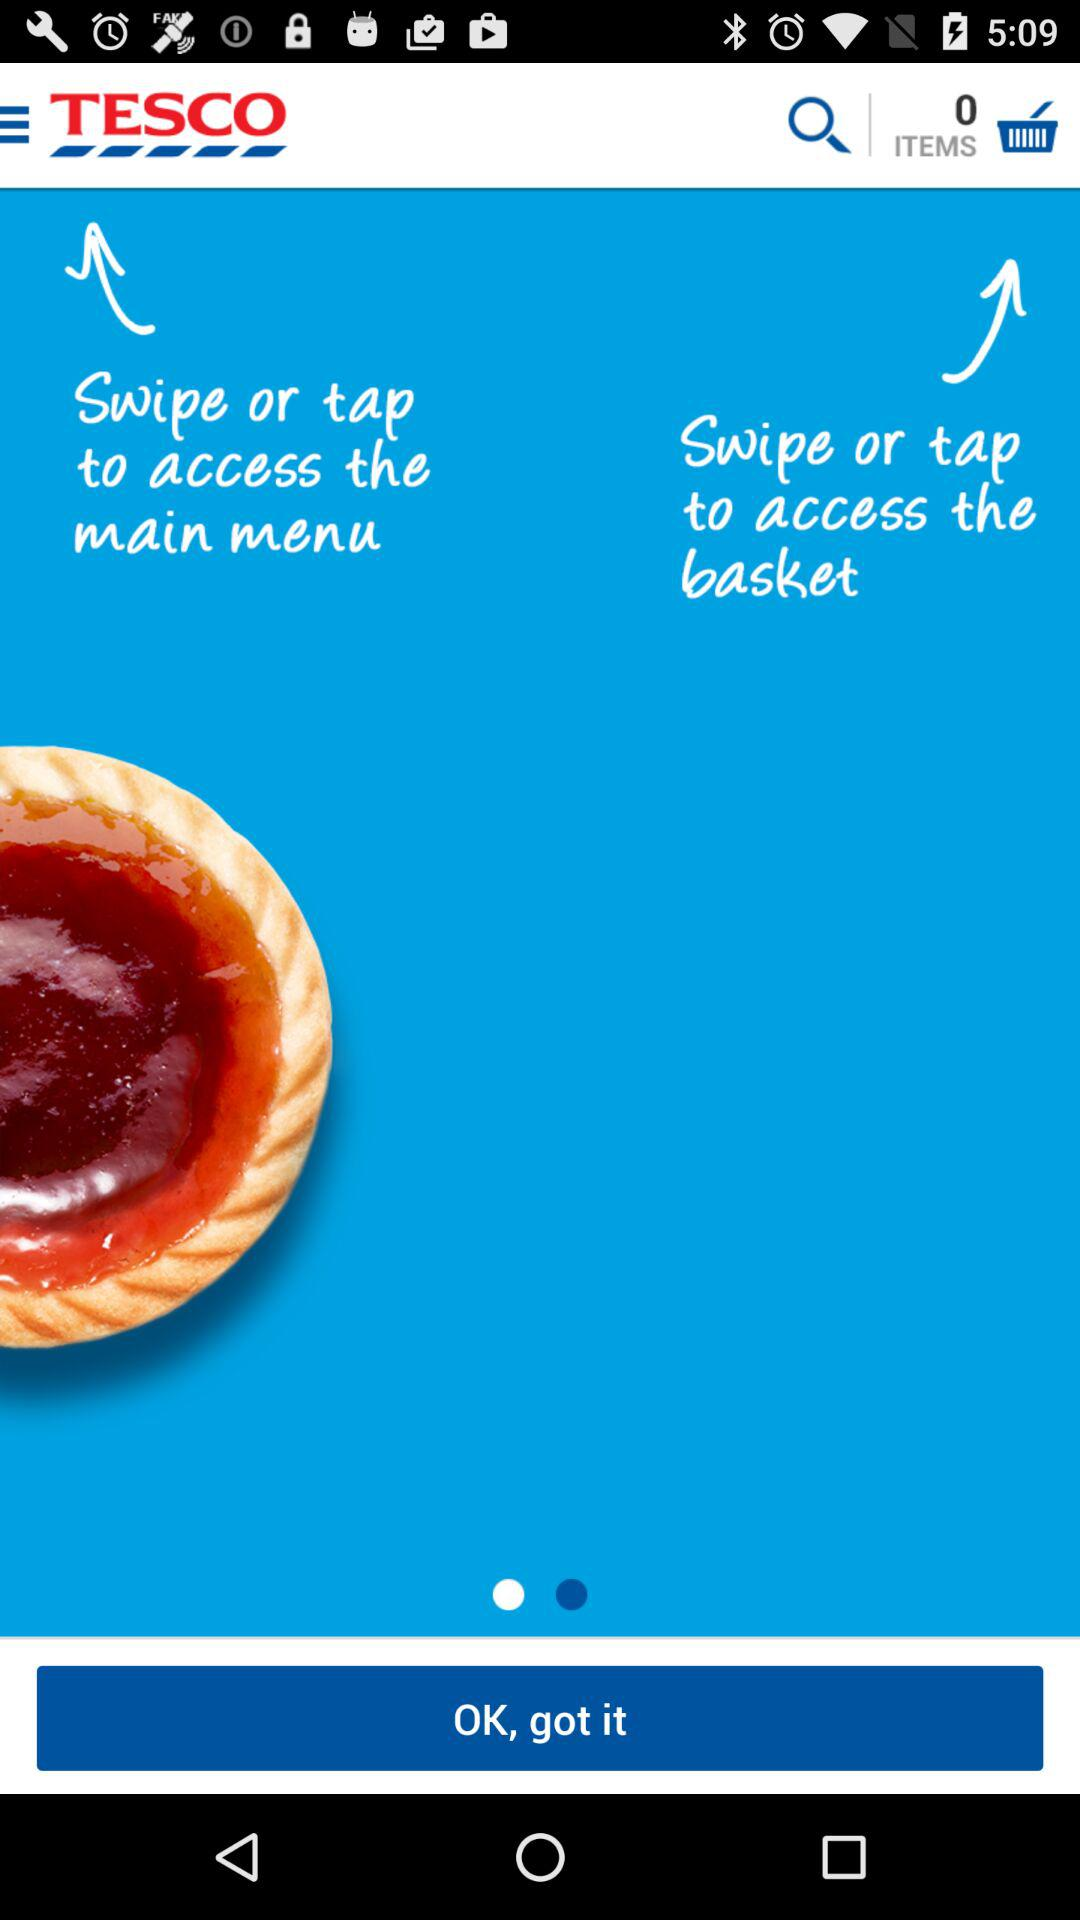What is the application name? The application name is "TESCO". 